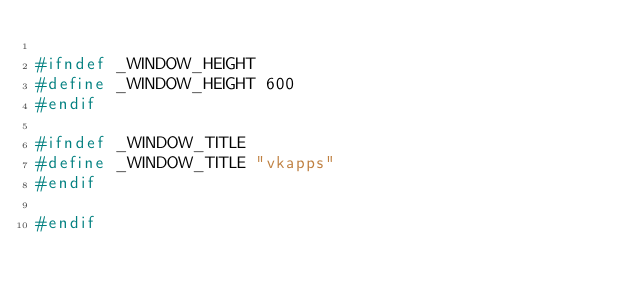Convert code to text. <code><loc_0><loc_0><loc_500><loc_500><_C_>
#ifndef _WINDOW_HEIGHT
#define _WINDOW_HEIGHT 600
#endif

#ifndef _WINDOW_TITLE
#define _WINDOW_TITLE "vkapps"
#endif

#endif
</code> 